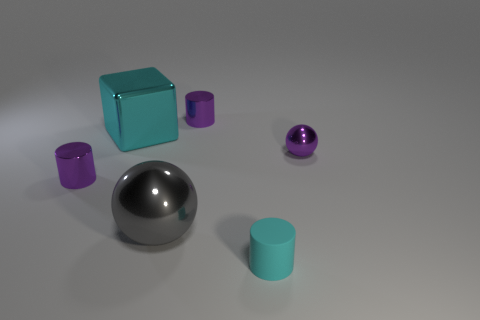Add 4 small cyan cylinders. How many objects exist? 10 Subtract all spheres. How many objects are left? 4 Add 3 big spheres. How many big spheres are left? 4 Add 3 cyan shiny blocks. How many cyan shiny blocks exist? 4 Subtract 0 cyan spheres. How many objects are left? 6 Subtract all metal spheres. Subtract all purple metallic cylinders. How many objects are left? 2 